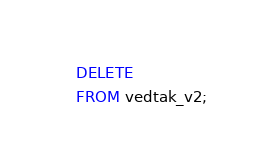<code> <loc_0><loc_0><loc_500><loc_500><_SQL_>DELETE
FROM vedtak_v2;
</code> 